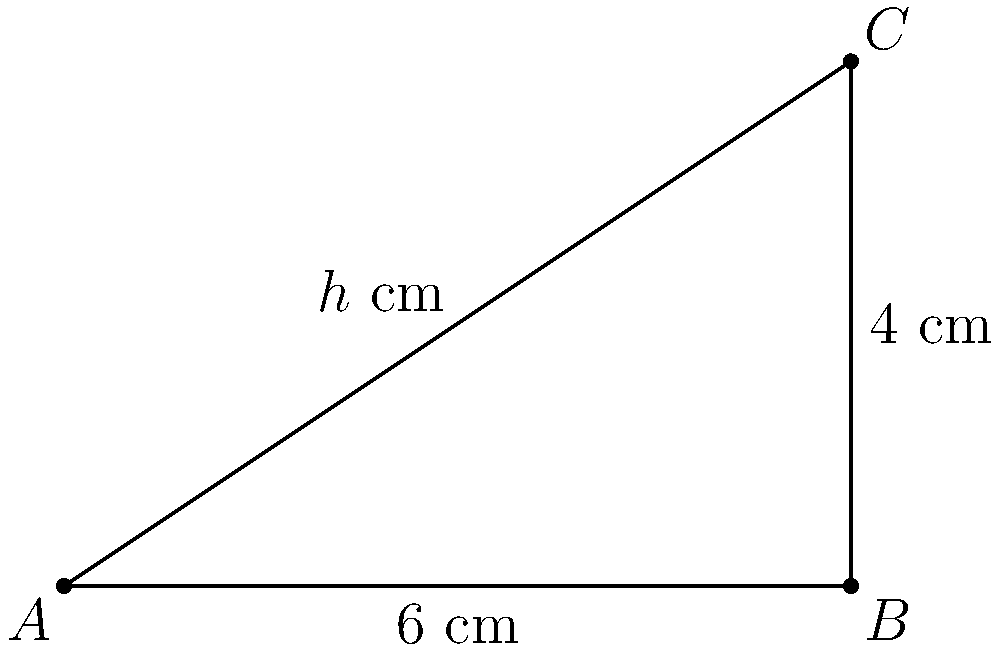A patient requires a medication dosage based on their body surface area (BSA). The BSA is approximated by a right triangle with a base of 6 cm and a height of 4 cm. The dosage is calculated as 5 mg per square cm of BSA. Using trigonometric formulas, calculate:

a) The length of the hypotenuse (h) in cm.
b) The area of the triangle in square cm.
c) The total dosage of medication in mg.

Round your final answer to the nearest whole number. Let's approach this step-by-step:

1) To find the hypotenuse (h), we can use the Pythagorean theorem:

   $$h^2 = 6^2 + 4^2$$
   $$h^2 = 36 + 16 = 52$$
   $$h = \sqrt{52} \approx 7.21 \text{ cm}$$

2) For the area of the triangle, we can use the basic formula:

   $$\text{Area} = \frac{1}{2} \times \text{base} \times \text{height}$$
   $$\text{Area} = \frac{1}{2} \times 6 \times 4 = 12 \text{ cm}^2$$

   Alternatively, we could use the trigonometric formula:
   $$\text{Area} = \frac{1}{2} \times 6 \times 4 \times \sin{90°} = 12 \text{ cm}^2$$

3) To calculate the total dosage:

   $$\text{Dosage} = 5 \text{ mg/cm}^2 \times 12 \text{ cm}^2 = 60 \text{ mg}$$

Therefore, the total dosage of medication is 60 mg.
Answer: 60 mg 